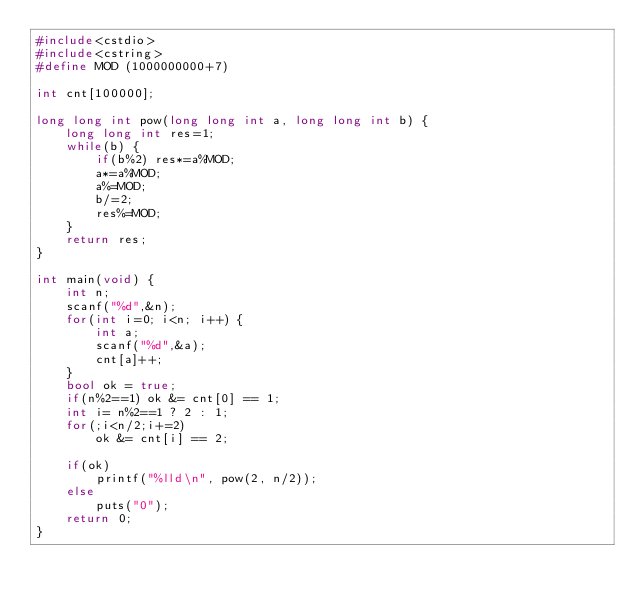Convert code to text. <code><loc_0><loc_0><loc_500><loc_500><_C++_>#include<cstdio>
#include<cstring>
#define MOD (1000000000+7)

int cnt[100000];

long long int pow(long long int a, long long int b) {
    long long int res=1;
    while(b) {
        if(b%2) res*=a%MOD;
        a*=a%MOD;
        a%=MOD;
        b/=2;
        res%=MOD;
    }
    return res;
}

int main(void) {
    int n;
    scanf("%d",&n);
    for(int i=0; i<n; i++) {
        int a;
        scanf("%d",&a);
        cnt[a]++;
    }
    bool ok = true;
    if(n%2==1) ok &= cnt[0] == 1;
    int i= n%2==1 ? 2 : 1;
    for(;i<n/2;i+=2)
        ok &= cnt[i] == 2;

    if(ok)
        printf("%lld\n", pow(2, n/2));
    else
        puts("0");
    return 0;
}</code> 